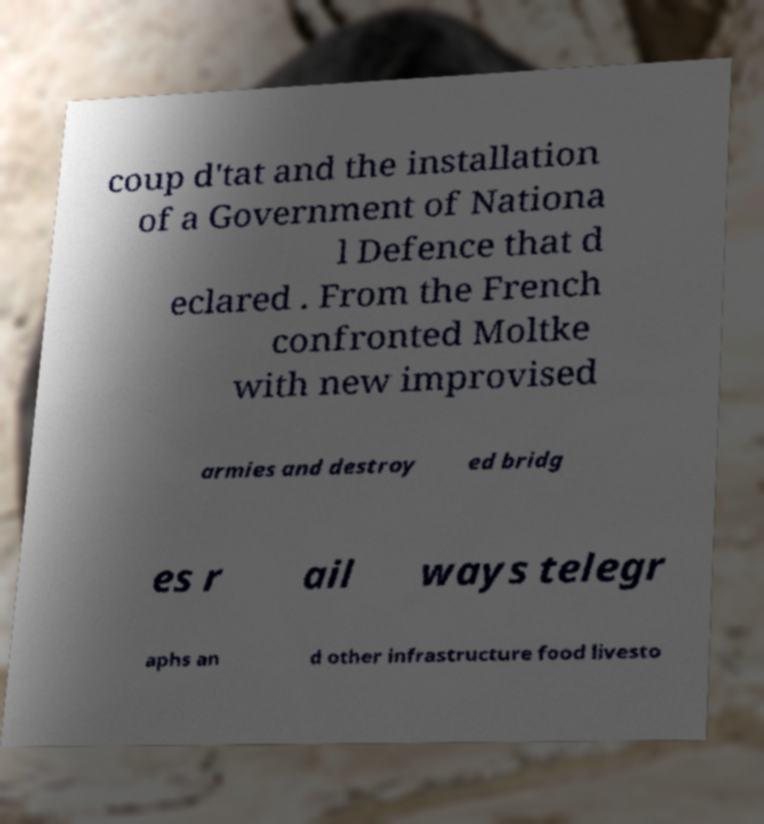Can you read and provide the text displayed in the image?This photo seems to have some interesting text. Can you extract and type it out for me? coup d'tat and the installation of a Government of Nationa l Defence that d eclared . From the French confronted Moltke with new improvised armies and destroy ed bridg es r ail ways telegr aphs an d other infrastructure food livesto 